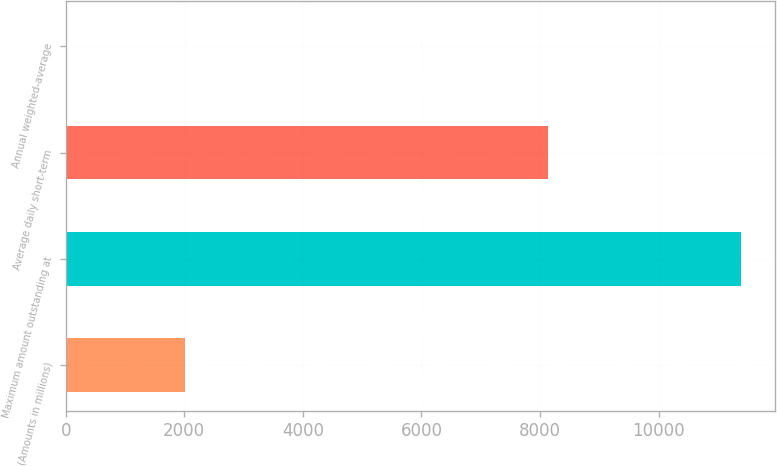Convert chart to OTSL. <chart><loc_0><loc_0><loc_500><loc_500><bar_chart><fcel>(Amounts in millions)<fcel>Maximum amount outstanding at<fcel>Average daily short-term<fcel>Annual weighted-average<nl><fcel>2018<fcel>11386<fcel>8131<fcel>1.3<nl></chart> 